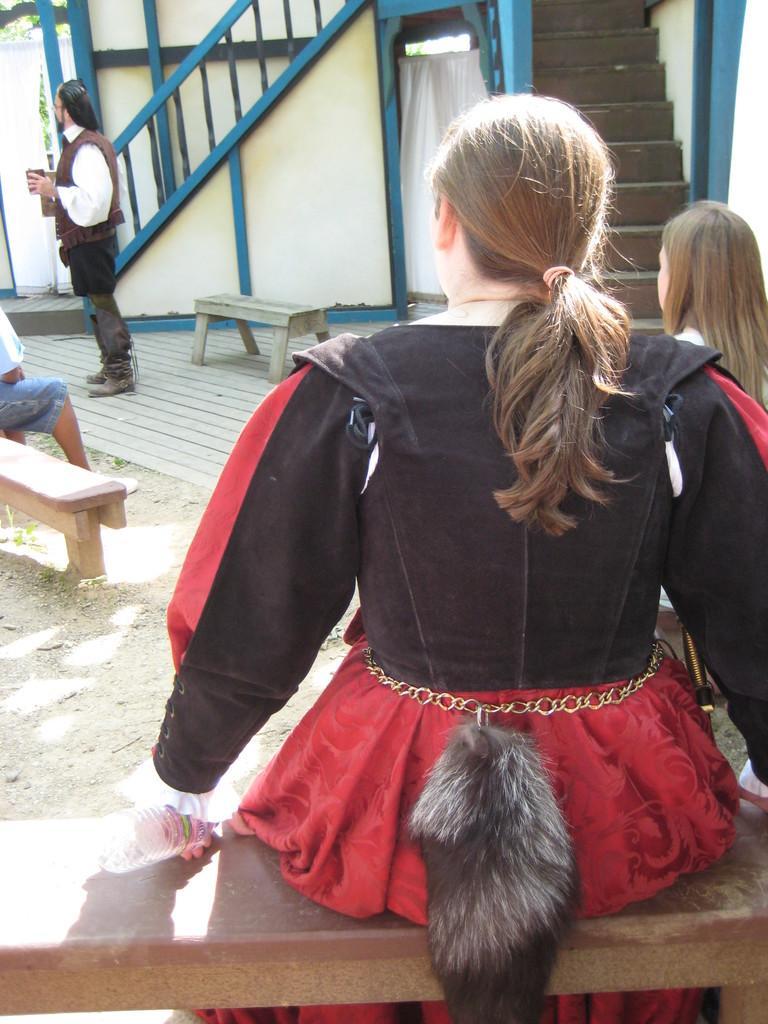How would you summarize this image in a sentence or two? These persons are sitting on the bench and this person standing. We can see staircases,wall,curtain. 